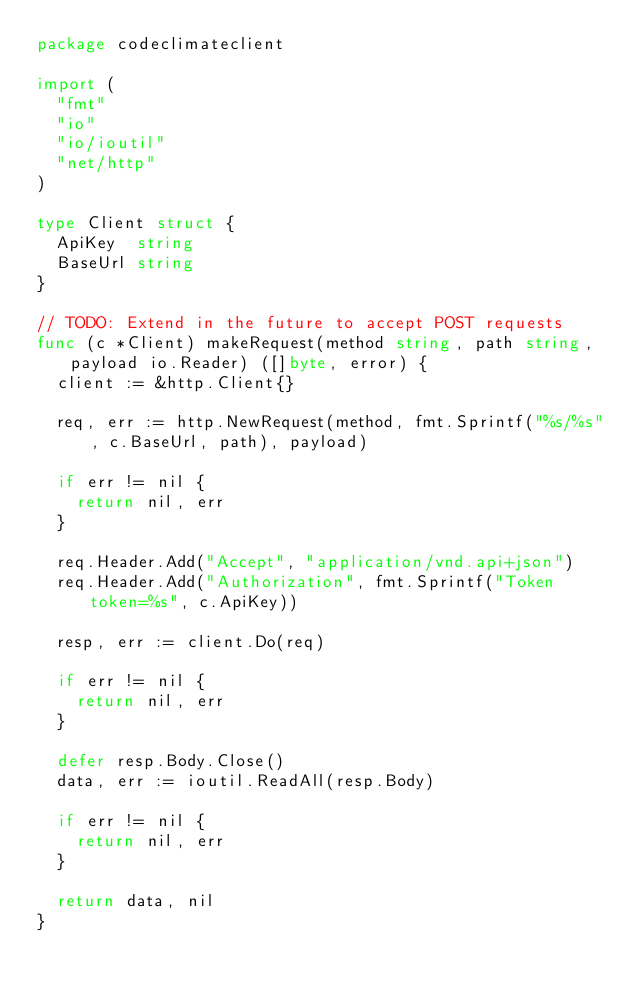Convert code to text. <code><loc_0><loc_0><loc_500><loc_500><_Go_>package codeclimateclient

import (
	"fmt"
	"io"
	"io/ioutil"
	"net/http"
)

type Client struct {
	ApiKey  string
	BaseUrl string
}

// TODO: Extend in the future to accept POST requests
func (c *Client) makeRequest(method string, path string, payload io.Reader) ([]byte, error) {
	client := &http.Client{}

	req, err := http.NewRequest(method, fmt.Sprintf("%s/%s", c.BaseUrl, path), payload)

	if err != nil {
		return nil, err
	}

	req.Header.Add("Accept", "application/vnd.api+json")
	req.Header.Add("Authorization", fmt.Sprintf("Token token=%s", c.ApiKey))

	resp, err := client.Do(req)

	if err != nil {
		return nil, err
	}

	defer resp.Body.Close()
	data, err := ioutil.ReadAll(resp.Body)

	if err != nil {
		return nil, err
	}

	return data, nil
}
</code> 